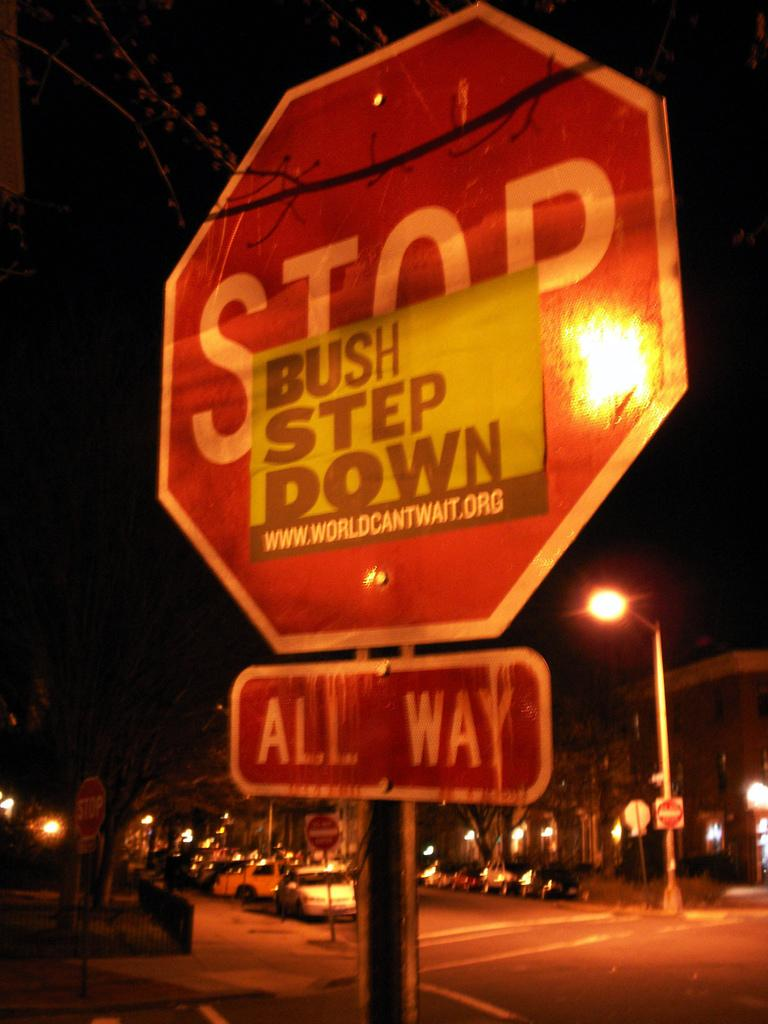<image>
Give a short and clear explanation of the subsequent image. a stop sign that says bush step down on it 